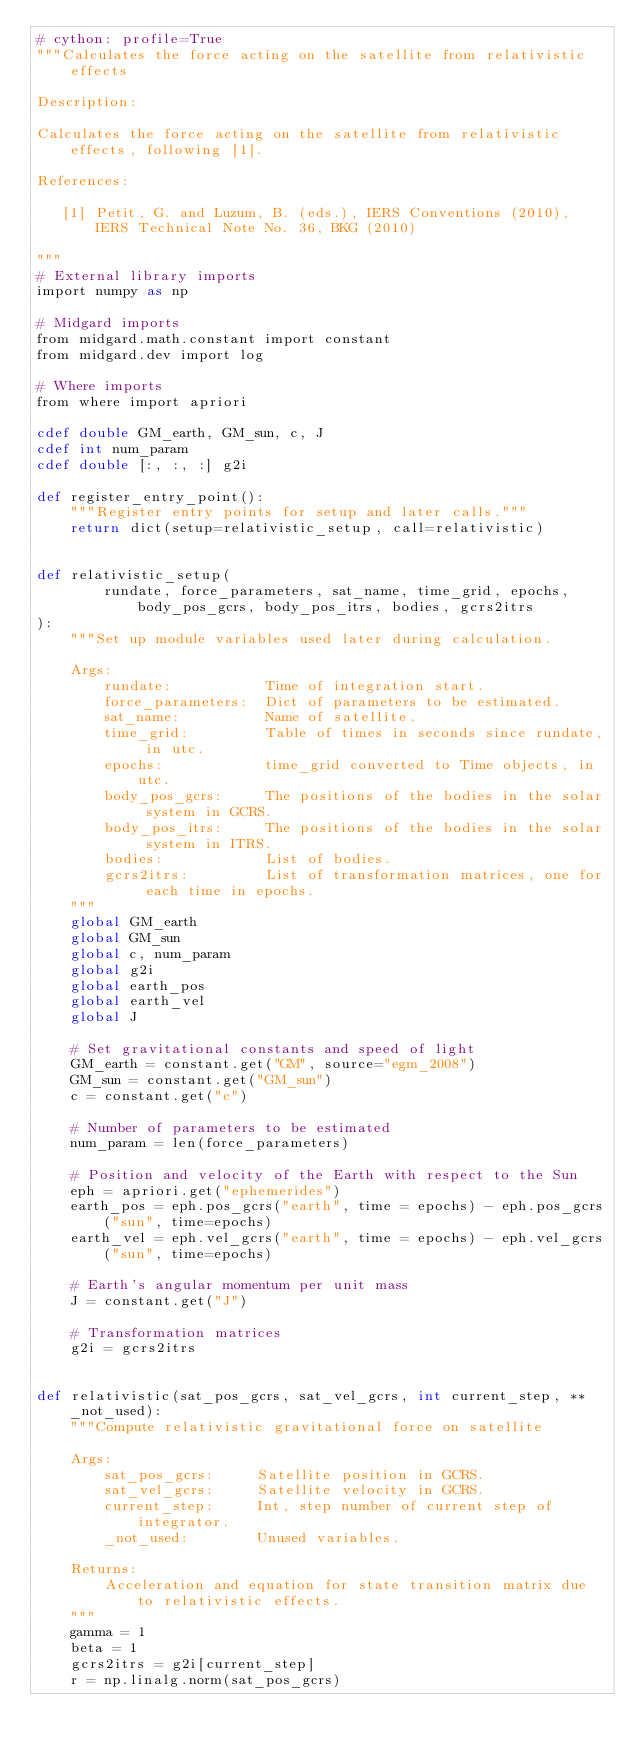<code> <loc_0><loc_0><loc_500><loc_500><_Cython_># cython: profile=True
"""Calculates the force acting on the satellite from relativistic effects

Description:

Calculates the force acting on the satellite from relativistic effects, following [1].

References:

   [1] Petit, G. and Luzum, B. (eds.), IERS Conventions (2010), IERS Technical Note No. 36, BKG (2010)

"""
# External library imports
import numpy as np

# Midgard imports
from midgard.math.constant import constant
from midgard.dev import log

# Where imports
from where import apriori

cdef double GM_earth, GM_sun, c, J
cdef int num_param
cdef double [:, :, :] g2i

def register_entry_point():
    """Register entry points for setup and later calls."""
    return dict(setup=relativistic_setup, call=relativistic)


def relativistic_setup(
        rundate, force_parameters, sat_name, time_grid, epochs, body_pos_gcrs, body_pos_itrs, bodies, gcrs2itrs
):
    """Set up module variables used later during calculation.

    Args:
        rundate:           Time of integration start.
        force_parameters:  Dict of parameters to be estimated.
        sat_name:          Name of satellite.
        time_grid:         Table of times in seconds since rundate, in utc.
        epochs:            time_grid converted to Time objects, in utc.
        body_pos_gcrs:     The positions of the bodies in the solar system in GCRS.
        body_pos_itrs:     The positions of the bodies in the solar system in ITRS.
        bodies:            List of bodies.
        gcrs2itrs:         List of transformation matrices, one for each time in epochs.
    """
    global GM_earth
    global GM_sun
    global c, num_param
    global g2i
    global earth_pos
    global earth_vel
    global J 
    
    # Set gravitational constants and speed of light
    GM_earth = constant.get("GM", source="egm_2008")
    GM_sun = constant.get("GM_sun")
    c = constant.get("c")

    # Number of parameters to be estimated
    num_param = len(force_parameters)

    # Position and velocity of the Earth with respect to the Sun
    eph = apriori.get("ephemerides")
    earth_pos = eph.pos_gcrs("earth", time = epochs) - eph.pos_gcrs("sun", time=epochs)
    earth_vel = eph.vel_gcrs("earth", time = epochs) - eph.vel_gcrs("sun", time=epochs)
    
    # Earth's angular momentum per unit mass
    J = constant.get("J")
    
    # Transformation matrices
    g2i = gcrs2itrs


def relativistic(sat_pos_gcrs, sat_vel_gcrs, int current_step, **_not_used):
    """Compute relativistic gravitational force on satellite

    Args:
        sat_pos_gcrs:     Satellite position in GCRS.
        sat_vel_gcrs:     Satellite velocity in GCRS.
        current_step:     Int, step number of current step of integrator.
        _not_used:        Unused variables.

    Returns:
        Acceleration and equation for state transition matrix due to relativistic effects.
    """
    gamma = 1
    beta = 1    
    gcrs2itrs = g2i[current_step]
    r = np.linalg.norm(sat_pos_gcrs)</code> 